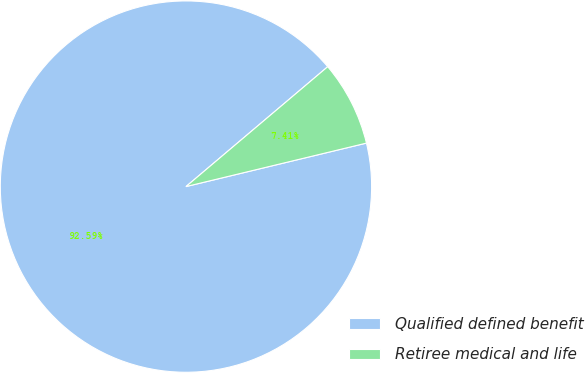Convert chart. <chart><loc_0><loc_0><loc_500><loc_500><pie_chart><fcel>Qualified defined benefit<fcel>Retiree medical and life<nl><fcel>92.59%<fcel>7.41%<nl></chart> 